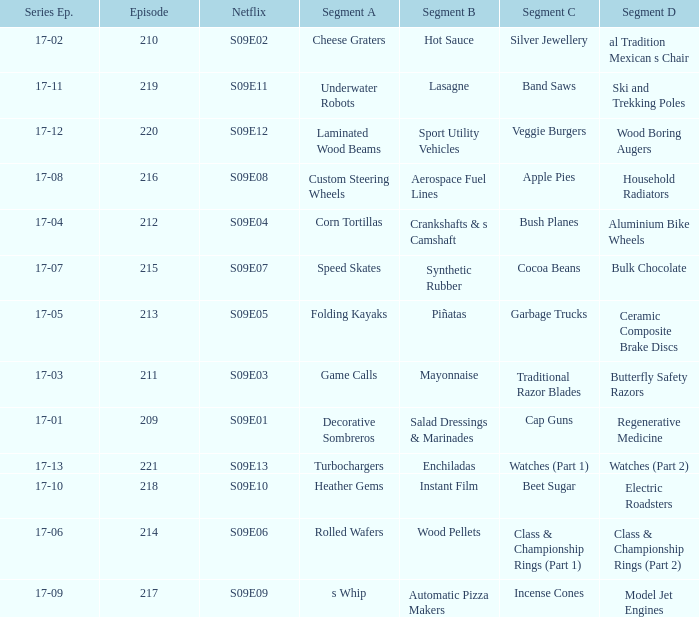Episode smaller than 210 had what segment c? Cap Guns. 